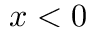Convert formula to latex. <formula><loc_0><loc_0><loc_500><loc_500>x < 0</formula> 